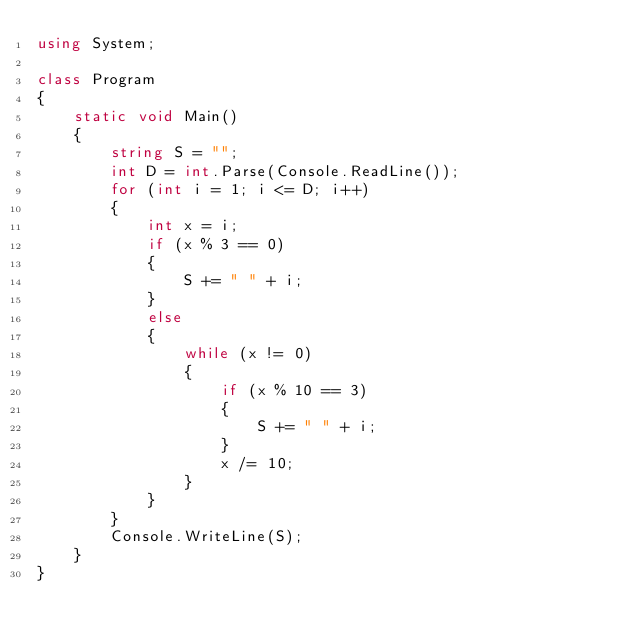<code> <loc_0><loc_0><loc_500><loc_500><_C#_>using System;

class Program
{
	static void Main()
	{
		string S = "";
		int D = int.Parse(Console.ReadLine());
		for (int i = 1; i <= D; i++)
		{
			int x = i;
			if (x % 3 == 0)
			{
				S += " " + i;
			}
			else
			{
				while (x != 0)
				{
					if (x % 10 == 3)
					{
						S += " " + i;
					}
					x /= 10;
				}
			}
		}
		Console.WriteLine(S);
	}
}</code> 